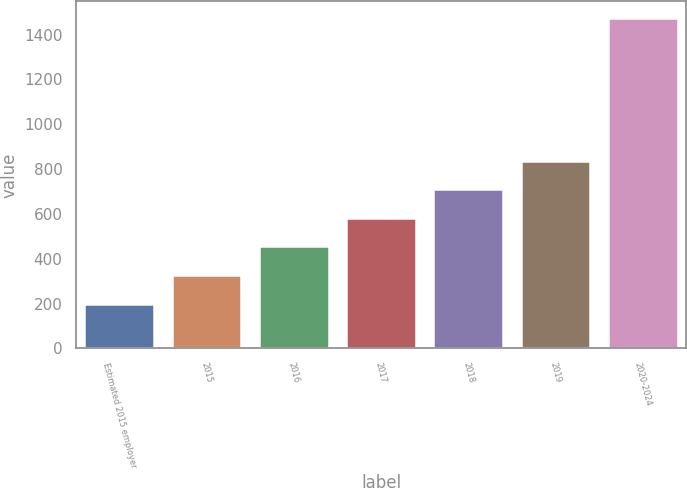Convert chart. <chart><loc_0><loc_0><loc_500><loc_500><bar_chart><fcel>Estimated 2015 employer<fcel>2015<fcel>2016<fcel>2017<fcel>2018<fcel>2019<fcel>2020-2024<nl><fcel>200<fcel>327.4<fcel>454.8<fcel>582.2<fcel>709.6<fcel>837<fcel>1474<nl></chart> 